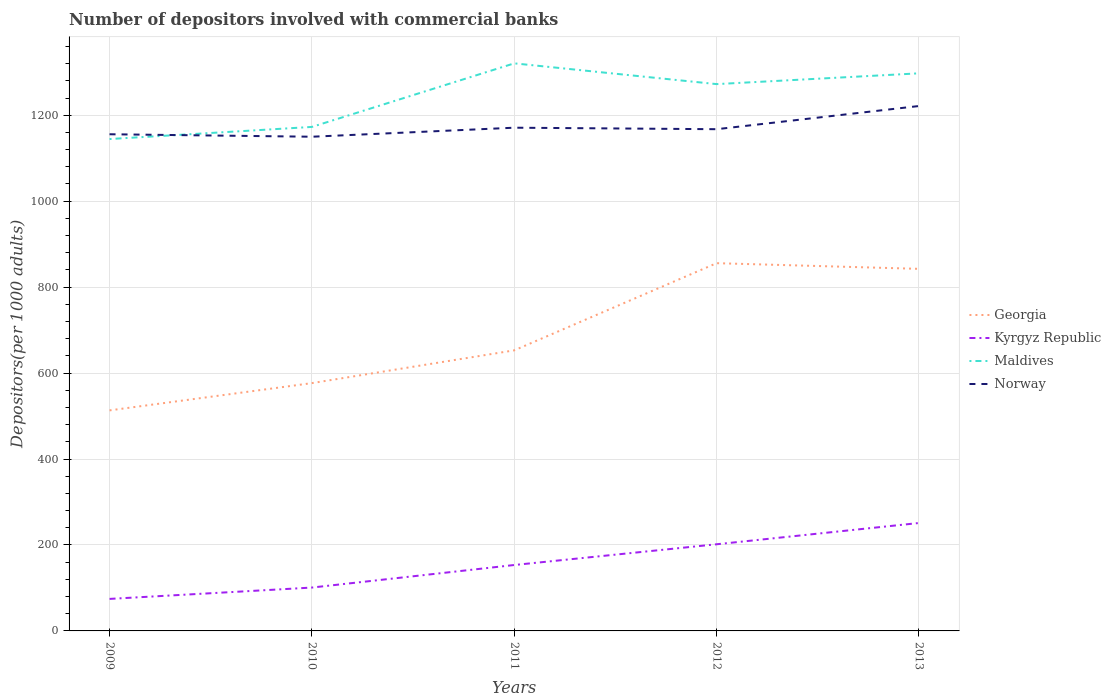How many different coloured lines are there?
Your response must be concise. 4. Does the line corresponding to Georgia intersect with the line corresponding to Norway?
Offer a terse response. No. Is the number of lines equal to the number of legend labels?
Keep it short and to the point. Yes. Across all years, what is the maximum number of depositors involved with commercial banks in Georgia?
Provide a short and direct response. 513.17. In which year was the number of depositors involved with commercial banks in Norway maximum?
Your answer should be very brief. 2010. What is the total number of depositors involved with commercial banks in Maldives in the graph?
Your response must be concise. -124.7. What is the difference between the highest and the second highest number of depositors involved with commercial banks in Maldives?
Your answer should be compact. 176.13. What is the difference between the highest and the lowest number of depositors involved with commercial banks in Norway?
Provide a succinct answer. 1. Is the number of depositors involved with commercial banks in Kyrgyz Republic strictly greater than the number of depositors involved with commercial banks in Norway over the years?
Your response must be concise. Yes. How many lines are there?
Give a very brief answer. 4. How many years are there in the graph?
Offer a very short reply. 5. Are the values on the major ticks of Y-axis written in scientific E-notation?
Ensure brevity in your answer.  No. Does the graph contain any zero values?
Provide a succinct answer. No. How are the legend labels stacked?
Provide a succinct answer. Vertical. What is the title of the graph?
Your response must be concise. Number of depositors involved with commercial banks. Does "Armenia" appear as one of the legend labels in the graph?
Ensure brevity in your answer.  No. What is the label or title of the X-axis?
Make the answer very short. Years. What is the label or title of the Y-axis?
Your answer should be compact. Depositors(per 1000 adults). What is the Depositors(per 1000 adults) of Georgia in 2009?
Your response must be concise. 513.17. What is the Depositors(per 1000 adults) of Kyrgyz Republic in 2009?
Your answer should be very brief. 74.51. What is the Depositors(per 1000 adults) in Maldives in 2009?
Ensure brevity in your answer.  1144.57. What is the Depositors(per 1000 adults) in Norway in 2009?
Make the answer very short. 1155.72. What is the Depositors(per 1000 adults) in Georgia in 2010?
Offer a terse response. 576.61. What is the Depositors(per 1000 adults) of Kyrgyz Republic in 2010?
Offer a terse response. 100.91. What is the Depositors(per 1000 adults) of Maldives in 2010?
Provide a succinct answer. 1172.79. What is the Depositors(per 1000 adults) in Norway in 2010?
Offer a very short reply. 1149.96. What is the Depositors(per 1000 adults) of Georgia in 2011?
Give a very brief answer. 652.89. What is the Depositors(per 1000 adults) in Kyrgyz Republic in 2011?
Your answer should be very brief. 153.38. What is the Depositors(per 1000 adults) in Maldives in 2011?
Give a very brief answer. 1320.69. What is the Depositors(per 1000 adults) in Norway in 2011?
Make the answer very short. 1170.97. What is the Depositors(per 1000 adults) of Georgia in 2012?
Provide a succinct answer. 855.71. What is the Depositors(per 1000 adults) of Kyrgyz Republic in 2012?
Your answer should be very brief. 201.64. What is the Depositors(per 1000 adults) of Maldives in 2012?
Provide a succinct answer. 1272.39. What is the Depositors(per 1000 adults) in Norway in 2012?
Your response must be concise. 1167.46. What is the Depositors(per 1000 adults) of Georgia in 2013?
Provide a short and direct response. 842.51. What is the Depositors(per 1000 adults) of Kyrgyz Republic in 2013?
Your response must be concise. 251.12. What is the Depositors(per 1000 adults) in Maldives in 2013?
Keep it short and to the point. 1297.48. What is the Depositors(per 1000 adults) of Norway in 2013?
Give a very brief answer. 1221.4. Across all years, what is the maximum Depositors(per 1000 adults) in Georgia?
Ensure brevity in your answer.  855.71. Across all years, what is the maximum Depositors(per 1000 adults) of Kyrgyz Republic?
Ensure brevity in your answer.  251.12. Across all years, what is the maximum Depositors(per 1000 adults) of Maldives?
Your answer should be compact. 1320.69. Across all years, what is the maximum Depositors(per 1000 adults) of Norway?
Your response must be concise. 1221.4. Across all years, what is the minimum Depositors(per 1000 adults) of Georgia?
Give a very brief answer. 513.17. Across all years, what is the minimum Depositors(per 1000 adults) of Kyrgyz Republic?
Your answer should be compact. 74.51. Across all years, what is the minimum Depositors(per 1000 adults) of Maldives?
Offer a very short reply. 1144.57. Across all years, what is the minimum Depositors(per 1000 adults) of Norway?
Your answer should be compact. 1149.96. What is the total Depositors(per 1000 adults) in Georgia in the graph?
Offer a terse response. 3440.89. What is the total Depositors(per 1000 adults) of Kyrgyz Republic in the graph?
Provide a short and direct response. 781.55. What is the total Depositors(per 1000 adults) in Maldives in the graph?
Your answer should be compact. 6207.91. What is the total Depositors(per 1000 adults) of Norway in the graph?
Provide a short and direct response. 5865.51. What is the difference between the Depositors(per 1000 adults) of Georgia in 2009 and that in 2010?
Your answer should be compact. -63.44. What is the difference between the Depositors(per 1000 adults) in Kyrgyz Republic in 2009 and that in 2010?
Offer a very short reply. -26.4. What is the difference between the Depositors(per 1000 adults) of Maldives in 2009 and that in 2010?
Provide a succinct answer. -28.22. What is the difference between the Depositors(per 1000 adults) of Norway in 2009 and that in 2010?
Give a very brief answer. 5.76. What is the difference between the Depositors(per 1000 adults) of Georgia in 2009 and that in 2011?
Offer a very short reply. -139.72. What is the difference between the Depositors(per 1000 adults) in Kyrgyz Republic in 2009 and that in 2011?
Ensure brevity in your answer.  -78.87. What is the difference between the Depositors(per 1000 adults) of Maldives in 2009 and that in 2011?
Keep it short and to the point. -176.13. What is the difference between the Depositors(per 1000 adults) in Norway in 2009 and that in 2011?
Ensure brevity in your answer.  -15.25. What is the difference between the Depositors(per 1000 adults) of Georgia in 2009 and that in 2012?
Keep it short and to the point. -342.55. What is the difference between the Depositors(per 1000 adults) of Kyrgyz Republic in 2009 and that in 2012?
Provide a succinct answer. -127.13. What is the difference between the Depositors(per 1000 adults) in Maldives in 2009 and that in 2012?
Your response must be concise. -127.82. What is the difference between the Depositors(per 1000 adults) in Norway in 2009 and that in 2012?
Offer a very short reply. -11.74. What is the difference between the Depositors(per 1000 adults) of Georgia in 2009 and that in 2013?
Ensure brevity in your answer.  -329.35. What is the difference between the Depositors(per 1000 adults) in Kyrgyz Republic in 2009 and that in 2013?
Provide a succinct answer. -176.61. What is the difference between the Depositors(per 1000 adults) in Maldives in 2009 and that in 2013?
Provide a short and direct response. -152.92. What is the difference between the Depositors(per 1000 adults) of Norway in 2009 and that in 2013?
Ensure brevity in your answer.  -65.68. What is the difference between the Depositors(per 1000 adults) of Georgia in 2010 and that in 2011?
Offer a terse response. -76.28. What is the difference between the Depositors(per 1000 adults) of Kyrgyz Republic in 2010 and that in 2011?
Your answer should be very brief. -52.48. What is the difference between the Depositors(per 1000 adults) of Maldives in 2010 and that in 2011?
Your answer should be compact. -147.91. What is the difference between the Depositors(per 1000 adults) of Norway in 2010 and that in 2011?
Offer a very short reply. -21.01. What is the difference between the Depositors(per 1000 adults) in Georgia in 2010 and that in 2012?
Make the answer very short. -279.11. What is the difference between the Depositors(per 1000 adults) of Kyrgyz Republic in 2010 and that in 2012?
Provide a succinct answer. -100.73. What is the difference between the Depositors(per 1000 adults) in Maldives in 2010 and that in 2012?
Make the answer very short. -99.6. What is the difference between the Depositors(per 1000 adults) in Norway in 2010 and that in 2012?
Your answer should be compact. -17.51. What is the difference between the Depositors(per 1000 adults) in Georgia in 2010 and that in 2013?
Offer a terse response. -265.9. What is the difference between the Depositors(per 1000 adults) in Kyrgyz Republic in 2010 and that in 2013?
Give a very brief answer. -150.21. What is the difference between the Depositors(per 1000 adults) in Maldives in 2010 and that in 2013?
Ensure brevity in your answer.  -124.7. What is the difference between the Depositors(per 1000 adults) of Norway in 2010 and that in 2013?
Give a very brief answer. -71.45. What is the difference between the Depositors(per 1000 adults) of Georgia in 2011 and that in 2012?
Give a very brief answer. -202.83. What is the difference between the Depositors(per 1000 adults) in Kyrgyz Republic in 2011 and that in 2012?
Your response must be concise. -48.25. What is the difference between the Depositors(per 1000 adults) of Maldives in 2011 and that in 2012?
Offer a very short reply. 48.3. What is the difference between the Depositors(per 1000 adults) of Norway in 2011 and that in 2012?
Your answer should be compact. 3.5. What is the difference between the Depositors(per 1000 adults) in Georgia in 2011 and that in 2013?
Give a very brief answer. -189.63. What is the difference between the Depositors(per 1000 adults) of Kyrgyz Republic in 2011 and that in 2013?
Ensure brevity in your answer.  -97.73. What is the difference between the Depositors(per 1000 adults) of Maldives in 2011 and that in 2013?
Ensure brevity in your answer.  23.21. What is the difference between the Depositors(per 1000 adults) of Norway in 2011 and that in 2013?
Keep it short and to the point. -50.44. What is the difference between the Depositors(per 1000 adults) of Georgia in 2012 and that in 2013?
Provide a succinct answer. 13.2. What is the difference between the Depositors(per 1000 adults) in Kyrgyz Republic in 2012 and that in 2013?
Keep it short and to the point. -49.48. What is the difference between the Depositors(per 1000 adults) in Maldives in 2012 and that in 2013?
Make the answer very short. -25.1. What is the difference between the Depositors(per 1000 adults) in Norway in 2012 and that in 2013?
Your response must be concise. -53.94. What is the difference between the Depositors(per 1000 adults) of Georgia in 2009 and the Depositors(per 1000 adults) of Kyrgyz Republic in 2010?
Your response must be concise. 412.26. What is the difference between the Depositors(per 1000 adults) in Georgia in 2009 and the Depositors(per 1000 adults) in Maldives in 2010?
Ensure brevity in your answer.  -659.62. What is the difference between the Depositors(per 1000 adults) of Georgia in 2009 and the Depositors(per 1000 adults) of Norway in 2010?
Keep it short and to the point. -636.79. What is the difference between the Depositors(per 1000 adults) in Kyrgyz Republic in 2009 and the Depositors(per 1000 adults) in Maldives in 2010?
Offer a terse response. -1098.28. What is the difference between the Depositors(per 1000 adults) in Kyrgyz Republic in 2009 and the Depositors(per 1000 adults) in Norway in 2010?
Make the answer very short. -1075.45. What is the difference between the Depositors(per 1000 adults) in Maldives in 2009 and the Depositors(per 1000 adults) in Norway in 2010?
Your answer should be compact. -5.39. What is the difference between the Depositors(per 1000 adults) in Georgia in 2009 and the Depositors(per 1000 adults) in Kyrgyz Republic in 2011?
Your answer should be compact. 359.78. What is the difference between the Depositors(per 1000 adults) of Georgia in 2009 and the Depositors(per 1000 adults) of Maldives in 2011?
Provide a succinct answer. -807.53. What is the difference between the Depositors(per 1000 adults) of Georgia in 2009 and the Depositors(per 1000 adults) of Norway in 2011?
Provide a short and direct response. -657.8. What is the difference between the Depositors(per 1000 adults) of Kyrgyz Republic in 2009 and the Depositors(per 1000 adults) of Maldives in 2011?
Provide a succinct answer. -1246.18. What is the difference between the Depositors(per 1000 adults) of Kyrgyz Republic in 2009 and the Depositors(per 1000 adults) of Norway in 2011?
Your answer should be compact. -1096.46. What is the difference between the Depositors(per 1000 adults) of Maldives in 2009 and the Depositors(per 1000 adults) of Norway in 2011?
Your answer should be compact. -26.4. What is the difference between the Depositors(per 1000 adults) of Georgia in 2009 and the Depositors(per 1000 adults) of Kyrgyz Republic in 2012?
Your answer should be compact. 311.53. What is the difference between the Depositors(per 1000 adults) in Georgia in 2009 and the Depositors(per 1000 adults) in Maldives in 2012?
Your answer should be very brief. -759.22. What is the difference between the Depositors(per 1000 adults) in Georgia in 2009 and the Depositors(per 1000 adults) in Norway in 2012?
Your answer should be very brief. -654.3. What is the difference between the Depositors(per 1000 adults) in Kyrgyz Republic in 2009 and the Depositors(per 1000 adults) in Maldives in 2012?
Your answer should be very brief. -1197.88. What is the difference between the Depositors(per 1000 adults) of Kyrgyz Republic in 2009 and the Depositors(per 1000 adults) of Norway in 2012?
Your response must be concise. -1092.95. What is the difference between the Depositors(per 1000 adults) of Maldives in 2009 and the Depositors(per 1000 adults) of Norway in 2012?
Your answer should be very brief. -22.9. What is the difference between the Depositors(per 1000 adults) in Georgia in 2009 and the Depositors(per 1000 adults) in Kyrgyz Republic in 2013?
Your answer should be compact. 262.05. What is the difference between the Depositors(per 1000 adults) in Georgia in 2009 and the Depositors(per 1000 adults) in Maldives in 2013?
Offer a very short reply. -784.32. What is the difference between the Depositors(per 1000 adults) of Georgia in 2009 and the Depositors(per 1000 adults) of Norway in 2013?
Keep it short and to the point. -708.24. What is the difference between the Depositors(per 1000 adults) of Kyrgyz Republic in 2009 and the Depositors(per 1000 adults) of Maldives in 2013?
Offer a very short reply. -1222.97. What is the difference between the Depositors(per 1000 adults) in Kyrgyz Republic in 2009 and the Depositors(per 1000 adults) in Norway in 2013?
Make the answer very short. -1146.89. What is the difference between the Depositors(per 1000 adults) in Maldives in 2009 and the Depositors(per 1000 adults) in Norway in 2013?
Your response must be concise. -76.84. What is the difference between the Depositors(per 1000 adults) of Georgia in 2010 and the Depositors(per 1000 adults) of Kyrgyz Republic in 2011?
Offer a terse response. 423.23. What is the difference between the Depositors(per 1000 adults) of Georgia in 2010 and the Depositors(per 1000 adults) of Maldives in 2011?
Make the answer very short. -744.08. What is the difference between the Depositors(per 1000 adults) of Georgia in 2010 and the Depositors(per 1000 adults) of Norway in 2011?
Make the answer very short. -594.36. What is the difference between the Depositors(per 1000 adults) in Kyrgyz Republic in 2010 and the Depositors(per 1000 adults) in Maldives in 2011?
Give a very brief answer. -1219.78. What is the difference between the Depositors(per 1000 adults) in Kyrgyz Republic in 2010 and the Depositors(per 1000 adults) in Norway in 2011?
Ensure brevity in your answer.  -1070.06. What is the difference between the Depositors(per 1000 adults) of Maldives in 2010 and the Depositors(per 1000 adults) of Norway in 2011?
Your response must be concise. 1.82. What is the difference between the Depositors(per 1000 adults) of Georgia in 2010 and the Depositors(per 1000 adults) of Kyrgyz Republic in 2012?
Offer a terse response. 374.97. What is the difference between the Depositors(per 1000 adults) in Georgia in 2010 and the Depositors(per 1000 adults) in Maldives in 2012?
Ensure brevity in your answer.  -695.78. What is the difference between the Depositors(per 1000 adults) of Georgia in 2010 and the Depositors(per 1000 adults) of Norway in 2012?
Make the answer very short. -590.86. What is the difference between the Depositors(per 1000 adults) of Kyrgyz Republic in 2010 and the Depositors(per 1000 adults) of Maldives in 2012?
Keep it short and to the point. -1171.48. What is the difference between the Depositors(per 1000 adults) in Kyrgyz Republic in 2010 and the Depositors(per 1000 adults) in Norway in 2012?
Provide a short and direct response. -1066.56. What is the difference between the Depositors(per 1000 adults) in Maldives in 2010 and the Depositors(per 1000 adults) in Norway in 2012?
Keep it short and to the point. 5.32. What is the difference between the Depositors(per 1000 adults) in Georgia in 2010 and the Depositors(per 1000 adults) in Kyrgyz Republic in 2013?
Provide a succinct answer. 325.49. What is the difference between the Depositors(per 1000 adults) in Georgia in 2010 and the Depositors(per 1000 adults) in Maldives in 2013?
Provide a succinct answer. -720.88. What is the difference between the Depositors(per 1000 adults) of Georgia in 2010 and the Depositors(per 1000 adults) of Norway in 2013?
Provide a short and direct response. -644.79. What is the difference between the Depositors(per 1000 adults) of Kyrgyz Republic in 2010 and the Depositors(per 1000 adults) of Maldives in 2013?
Give a very brief answer. -1196.58. What is the difference between the Depositors(per 1000 adults) of Kyrgyz Republic in 2010 and the Depositors(per 1000 adults) of Norway in 2013?
Your response must be concise. -1120.5. What is the difference between the Depositors(per 1000 adults) in Maldives in 2010 and the Depositors(per 1000 adults) in Norway in 2013?
Provide a short and direct response. -48.62. What is the difference between the Depositors(per 1000 adults) in Georgia in 2011 and the Depositors(per 1000 adults) in Kyrgyz Republic in 2012?
Provide a short and direct response. 451.25. What is the difference between the Depositors(per 1000 adults) in Georgia in 2011 and the Depositors(per 1000 adults) in Maldives in 2012?
Offer a very short reply. -619.5. What is the difference between the Depositors(per 1000 adults) in Georgia in 2011 and the Depositors(per 1000 adults) in Norway in 2012?
Keep it short and to the point. -514.58. What is the difference between the Depositors(per 1000 adults) in Kyrgyz Republic in 2011 and the Depositors(per 1000 adults) in Maldives in 2012?
Your response must be concise. -1119. What is the difference between the Depositors(per 1000 adults) of Kyrgyz Republic in 2011 and the Depositors(per 1000 adults) of Norway in 2012?
Give a very brief answer. -1014.08. What is the difference between the Depositors(per 1000 adults) of Maldives in 2011 and the Depositors(per 1000 adults) of Norway in 2012?
Ensure brevity in your answer.  153.23. What is the difference between the Depositors(per 1000 adults) of Georgia in 2011 and the Depositors(per 1000 adults) of Kyrgyz Republic in 2013?
Provide a short and direct response. 401.77. What is the difference between the Depositors(per 1000 adults) in Georgia in 2011 and the Depositors(per 1000 adults) in Maldives in 2013?
Make the answer very short. -644.6. What is the difference between the Depositors(per 1000 adults) in Georgia in 2011 and the Depositors(per 1000 adults) in Norway in 2013?
Provide a short and direct response. -568.52. What is the difference between the Depositors(per 1000 adults) of Kyrgyz Republic in 2011 and the Depositors(per 1000 adults) of Maldives in 2013?
Your answer should be compact. -1144.1. What is the difference between the Depositors(per 1000 adults) of Kyrgyz Republic in 2011 and the Depositors(per 1000 adults) of Norway in 2013?
Offer a very short reply. -1068.02. What is the difference between the Depositors(per 1000 adults) of Maldives in 2011 and the Depositors(per 1000 adults) of Norway in 2013?
Provide a short and direct response. 99.29. What is the difference between the Depositors(per 1000 adults) in Georgia in 2012 and the Depositors(per 1000 adults) in Kyrgyz Republic in 2013?
Ensure brevity in your answer.  604.6. What is the difference between the Depositors(per 1000 adults) in Georgia in 2012 and the Depositors(per 1000 adults) in Maldives in 2013?
Provide a succinct answer. -441.77. What is the difference between the Depositors(per 1000 adults) in Georgia in 2012 and the Depositors(per 1000 adults) in Norway in 2013?
Ensure brevity in your answer.  -365.69. What is the difference between the Depositors(per 1000 adults) of Kyrgyz Republic in 2012 and the Depositors(per 1000 adults) of Maldives in 2013?
Give a very brief answer. -1095.85. What is the difference between the Depositors(per 1000 adults) in Kyrgyz Republic in 2012 and the Depositors(per 1000 adults) in Norway in 2013?
Your answer should be compact. -1019.77. What is the difference between the Depositors(per 1000 adults) of Maldives in 2012 and the Depositors(per 1000 adults) of Norway in 2013?
Your response must be concise. 50.98. What is the average Depositors(per 1000 adults) in Georgia per year?
Provide a succinct answer. 688.18. What is the average Depositors(per 1000 adults) of Kyrgyz Republic per year?
Keep it short and to the point. 156.31. What is the average Depositors(per 1000 adults) of Maldives per year?
Your response must be concise. 1241.58. What is the average Depositors(per 1000 adults) of Norway per year?
Ensure brevity in your answer.  1173.1. In the year 2009, what is the difference between the Depositors(per 1000 adults) in Georgia and Depositors(per 1000 adults) in Kyrgyz Republic?
Provide a short and direct response. 438.66. In the year 2009, what is the difference between the Depositors(per 1000 adults) in Georgia and Depositors(per 1000 adults) in Maldives?
Give a very brief answer. -631.4. In the year 2009, what is the difference between the Depositors(per 1000 adults) of Georgia and Depositors(per 1000 adults) of Norway?
Your answer should be very brief. -642.56. In the year 2009, what is the difference between the Depositors(per 1000 adults) of Kyrgyz Republic and Depositors(per 1000 adults) of Maldives?
Provide a short and direct response. -1070.06. In the year 2009, what is the difference between the Depositors(per 1000 adults) in Kyrgyz Republic and Depositors(per 1000 adults) in Norway?
Your response must be concise. -1081.21. In the year 2009, what is the difference between the Depositors(per 1000 adults) in Maldives and Depositors(per 1000 adults) in Norway?
Offer a terse response. -11.16. In the year 2010, what is the difference between the Depositors(per 1000 adults) in Georgia and Depositors(per 1000 adults) in Kyrgyz Republic?
Provide a short and direct response. 475.7. In the year 2010, what is the difference between the Depositors(per 1000 adults) in Georgia and Depositors(per 1000 adults) in Maldives?
Your answer should be compact. -596.18. In the year 2010, what is the difference between the Depositors(per 1000 adults) in Georgia and Depositors(per 1000 adults) in Norway?
Offer a terse response. -573.35. In the year 2010, what is the difference between the Depositors(per 1000 adults) of Kyrgyz Republic and Depositors(per 1000 adults) of Maldives?
Your response must be concise. -1071.88. In the year 2010, what is the difference between the Depositors(per 1000 adults) of Kyrgyz Republic and Depositors(per 1000 adults) of Norway?
Offer a very short reply. -1049.05. In the year 2010, what is the difference between the Depositors(per 1000 adults) of Maldives and Depositors(per 1000 adults) of Norway?
Offer a very short reply. 22.83. In the year 2011, what is the difference between the Depositors(per 1000 adults) of Georgia and Depositors(per 1000 adults) of Kyrgyz Republic?
Provide a short and direct response. 499.5. In the year 2011, what is the difference between the Depositors(per 1000 adults) of Georgia and Depositors(per 1000 adults) of Maldives?
Offer a terse response. -667.81. In the year 2011, what is the difference between the Depositors(per 1000 adults) in Georgia and Depositors(per 1000 adults) in Norway?
Your answer should be compact. -518.08. In the year 2011, what is the difference between the Depositors(per 1000 adults) in Kyrgyz Republic and Depositors(per 1000 adults) in Maldives?
Offer a terse response. -1167.31. In the year 2011, what is the difference between the Depositors(per 1000 adults) in Kyrgyz Republic and Depositors(per 1000 adults) in Norway?
Offer a very short reply. -1017.58. In the year 2011, what is the difference between the Depositors(per 1000 adults) in Maldives and Depositors(per 1000 adults) in Norway?
Offer a terse response. 149.73. In the year 2012, what is the difference between the Depositors(per 1000 adults) in Georgia and Depositors(per 1000 adults) in Kyrgyz Republic?
Make the answer very short. 654.08. In the year 2012, what is the difference between the Depositors(per 1000 adults) in Georgia and Depositors(per 1000 adults) in Maldives?
Offer a terse response. -416.67. In the year 2012, what is the difference between the Depositors(per 1000 adults) of Georgia and Depositors(per 1000 adults) of Norway?
Give a very brief answer. -311.75. In the year 2012, what is the difference between the Depositors(per 1000 adults) of Kyrgyz Republic and Depositors(per 1000 adults) of Maldives?
Make the answer very short. -1070.75. In the year 2012, what is the difference between the Depositors(per 1000 adults) of Kyrgyz Republic and Depositors(per 1000 adults) of Norway?
Your response must be concise. -965.83. In the year 2012, what is the difference between the Depositors(per 1000 adults) in Maldives and Depositors(per 1000 adults) in Norway?
Your answer should be very brief. 104.92. In the year 2013, what is the difference between the Depositors(per 1000 adults) in Georgia and Depositors(per 1000 adults) in Kyrgyz Republic?
Give a very brief answer. 591.4. In the year 2013, what is the difference between the Depositors(per 1000 adults) of Georgia and Depositors(per 1000 adults) of Maldives?
Keep it short and to the point. -454.97. In the year 2013, what is the difference between the Depositors(per 1000 adults) of Georgia and Depositors(per 1000 adults) of Norway?
Your response must be concise. -378.89. In the year 2013, what is the difference between the Depositors(per 1000 adults) in Kyrgyz Republic and Depositors(per 1000 adults) in Maldives?
Your answer should be compact. -1046.37. In the year 2013, what is the difference between the Depositors(per 1000 adults) in Kyrgyz Republic and Depositors(per 1000 adults) in Norway?
Ensure brevity in your answer.  -970.29. In the year 2013, what is the difference between the Depositors(per 1000 adults) of Maldives and Depositors(per 1000 adults) of Norway?
Make the answer very short. 76.08. What is the ratio of the Depositors(per 1000 adults) of Georgia in 2009 to that in 2010?
Make the answer very short. 0.89. What is the ratio of the Depositors(per 1000 adults) in Kyrgyz Republic in 2009 to that in 2010?
Give a very brief answer. 0.74. What is the ratio of the Depositors(per 1000 adults) of Maldives in 2009 to that in 2010?
Offer a very short reply. 0.98. What is the ratio of the Depositors(per 1000 adults) in Georgia in 2009 to that in 2011?
Your answer should be compact. 0.79. What is the ratio of the Depositors(per 1000 adults) in Kyrgyz Republic in 2009 to that in 2011?
Offer a very short reply. 0.49. What is the ratio of the Depositors(per 1000 adults) in Maldives in 2009 to that in 2011?
Provide a short and direct response. 0.87. What is the ratio of the Depositors(per 1000 adults) of Norway in 2009 to that in 2011?
Give a very brief answer. 0.99. What is the ratio of the Depositors(per 1000 adults) of Georgia in 2009 to that in 2012?
Your answer should be compact. 0.6. What is the ratio of the Depositors(per 1000 adults) of Kyrgyz Republic in 2009 to that in 2012?
Ensure brevity in your answer.  0.37. What is the ratio of the Depositors(per 1000 adults) in Maldives in 2009 to that in 2012?
Offer a very short reply. 0.9. What is the ratio of the Depositors(per 1000 adults) in Georgia in 2009 to that in 2013?
Provide a succinct answer. 0.61. What is the ratio of the Depositors(per 1000 adults) of Kyrgyz Republic in 2009 to that in 2013?
Make the answer very short. 0.3. What is the ratio of the Depositors(per 1000 adults) of Maldives in 2009 to that in 2013?
Your answer should be very brief. 0.88. What is the ratio of the Depositors(per 1000 adults) of Norway in 2009 to that in 2013?
Ensure brevity in your answer.  0.95. What is the ratio of the Depositors(per 1000 adults) of Georgia in 2010 to that in 2011?
Your response must be concise. 0.88. What is the ratio of the Depositors(per 1000 adults) in Kyrgyz Republic in 2010 to that in 2011?
Your answer should be compact. 0.66. What is the ratio of the Depositors(per 1000 adults) of Maldives in 2010 to that in 2011?
Make the answer very short. 0.89. What is the ratio of the Depositors(per 1000 adults) in Norway in 2010 to that in 2011?
Offer a very short reply. 0.98. What is the ratio of the Depositors(per 1000 adults) of Georgia in 2010 to that in 2012?
Provide a short and direct response. 0.67. What is the ratio of the Depositors(per 1000 adults) in Kyrgyz Republic in 2010 to that in 2012?
Give a very brief answer. 0.5. What is the ratio of the Depositors(per 1000 adults) in Maldives in 2010 to that in 2012?
Provide a short and direct response. 0.92. What is the ratio of the Depositors(per 1000 adults) in Georgia in 2010 to that in 2013?
Your answer should be compact. 0.68. What is the ratio of the Depositors(per 1000 adults) in Kyrgyz Republic in 2010 to that in 2013?
Give a very brief answer. 0.4. What is the ratio of the Depositors(per 1000 adults) of Maldives in 2010 to that in 2013?
Offer a very short reply. 0.9. What is the ratio of the Depositors(per 1000 adults) of Norway in 2010 to that in 2013?
Make the answer very short. 0.94. What is the ratio of the Depositors(per 1000 adults) in Georgia in 2011 to that in 2012?
Ensure brevity in your answer.  0.76. What is the ratio of the Depositors(per 1000 adults) in Kyrgyz Republic in 2011 to that in 2012?
Offer a terse response. 0.76. What is the ratio of the Depositors(per 1000 adults) of Maldives in 2011 to that in 2012?
Keep it short and to the point. 1.04. What is the ratio of the Depositors(per 1000 adults) in Norway in 2011 to that in 2012?
Your answer should be compact. 1. What is the ratio of the Depositors(per 1000 adults) in Georgia in 2011 to that in 2013?
Provide a succinct answer. 0.77. What is the ratio of the Depositors(per 1000 adults) in Kyrgyz Republic in 2011 to that in 2013?
Ensure brevity in your answer.  0.61. What is the ratio of the Depositors(per 1000 adults) in Maldives in 2011 to that in 2013?
Your answer should be compact. 1.02. What is the ratio of the Depositors(per 1000 adults) of Norway in 2011 to that in 2013?
Make the answer very short. 0.96. What is the ratio of the Depositors(per 1000 adults) of Georgia in 2012 to that in 2013?
Offer a very short reply. 1.02. What is the ratio of the Depositors(per 1000 adults) in Kyrgyz Republic in 2012 to that in 2013?
Make the answer very short. 0.8. What is the ratio of the Depositors(per 1000 adults) of Maldives in 2012 to that in 2013?
Offer a very short reply. 0.98. What is the ratio of the Depositors(per 1000 adults) in Norway in 2012 to that in 2013?
Make the answer very short. 0.96. What is the difference between the highest and the second highest Depositors(per 1000 adults) in Georgia?
Provide a short and direct response. 13.2. What is the difference between the highest and the second highest Depositors(per 1000 adults) in Kyrgyz Republic?
Offer a terse response. 49.48. What is the difference between the highest and the second highest Depositors(per 1000 adults) of Maldives?
Give a very brief answer. 23.21. What is the difference between the highest and the second highest Depositors(per 1000 adults) in Norway?
Provide a short and direct response. 50.44. What is the difference between the highest and the lowest Depositors(per 1000 adults) in Georgia?
Provide a short and direct response. 342.55. What is the difference between the highest and the lowest Depositors(per 1000 adults) of Kyrgyz Republic?
Offer a very short reply. 176.61. What is the difference between the highest and the lowest Depositors(per 1000 adults) of Maldives?
Offer a very short reply. 176.13. What is the difference between the highest and the lowest Depositors(per 1000 adults) of Norway?
Your answer should be compact. 71.45. 